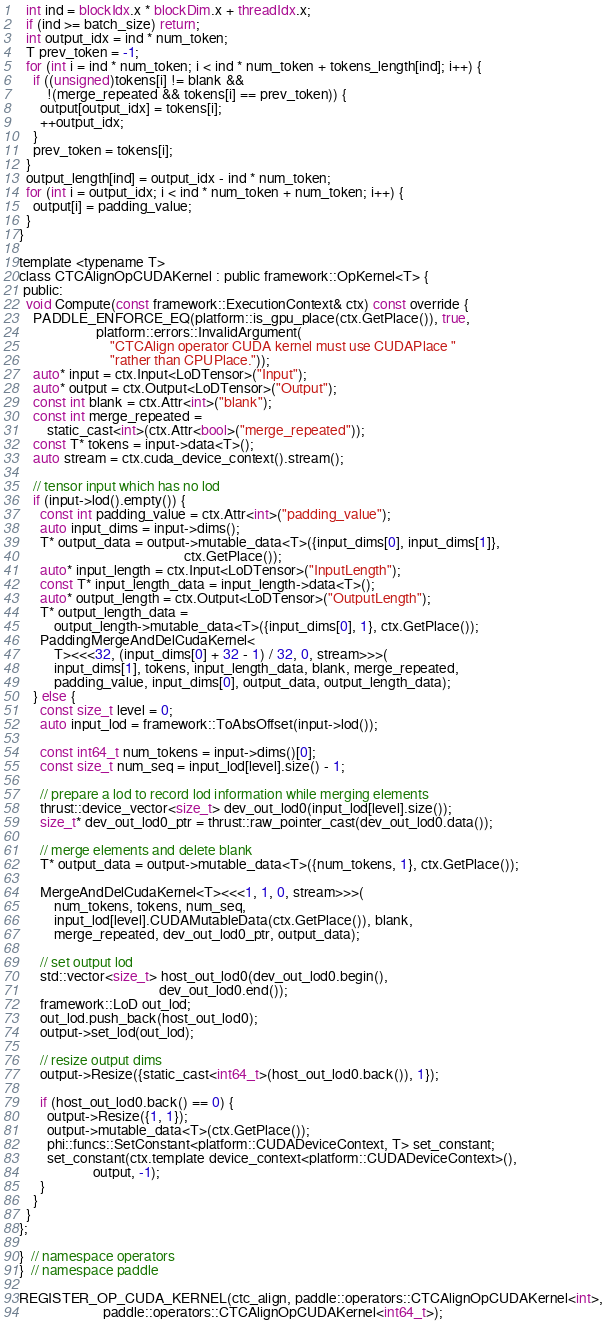<code> <loc_0><loc_0><loc_500><loc_500><_Cuda_>  int ind = blockIdx.x * blockDim.x + threadIdx.x;
  if (ind >= batch_size) return;
  int output_idx = ind * num_token;
  T prev_token = -1;
  for (int i = ind * num_token; i < ind * num_token + tokens_length[ind]; i++) {
    if ((unsigned)tokens[i] != blank &&
        !(merge_repeated && tokens[i] == prev_token)) {
      output[output_idx] = tokens[i];
      ++output_idx;
    }
    prev_token = tokens[i];
  }
  output_length[ind] = output_idx - ind * num_token;
  for (int i = output_idx; i < ind * num_token + num_token; i++) {
    output[i] = padding_value;
  }
}

template <typename T>
class CTCAlignOpCUDAKernel : public framework::OpKernel<T> {
 public:
  void Compute(const framework::ExecutionContext& ctx) const override {
    PADDLE_ENFORCE_EQ(platform::is_gpu_place(ctx.GetPlace()), true,
                      platform::errors::InvalidArgument(
                          "CTCAlign operator CUDA kernel must use CUDAPlace "
                          "rather than CPUPlace."));
    auto* input = ctx.Input<LoDTensor>("Input");
    auto* output = ctx.Output<LoDTensor>("Output");
    const int blank = ctx.Attr<int>("blank");
    const int merge_repeated =
        static_cast<int>(ctx.Attr<bool>("merge_repeated"));
    const T* tokens = input->data<T>();
    auto stream = ctx.cuda_device_context().stream();

    // tensor input which has no lod
    if (input->lod().empty()) {
      const int padding_value = ctx.Attr<int>("padding_value");
      auto input_dims = input->dims();
      T* output_data = output->mutable_data<T>({input_dims[0], input_dims[1]},
                                               ctx.GetPlace());
      auto* input_length = ctx.Input<LoDTensor>("InputLength");
      const T* input_length_data = input_length->data<T>();
      auto* output_length = ctx.Output<LoDTensor>("OutputLength");
      T* output_length_data =
          output_length->mutable_data<T>({input_dims[0], 1}, ctx.GetPlace());
      PaddingMergeAndDelCudaKernel<
          T><<<32, (input_dims[0] + 32 - 1) / 32, 0, stream>>>(
          input_dims[1], tokens, input_length_data, blank, merge_repeated,
          padding_value, input_dims[0], output_data, output_length_data);
    } else {
      const size_t level = 0;
      auto input_lod = framework::ToAbsOffset(input->lod());

      const int64_t num_tokens = input->dims()[0];
      const size_t num_seq = input_lod[level].size() - 1;

      // prepare a lod to record lod information while merging elements
      thrust::device_vector<size_t> dev_out_lod0(input_lod[level].size());
      size_t* dev_out_lod0_ptr = thrust::raw_pointer_cast(dev_out_lod0.data());

      // merge elements and delete blank
      T* output_data = output->mutable_data<T>({num_tokens, 1}, ctx.GetPlace());

      MergeAndDelCudaKernel<T><<<1, 1, 0, stream>>>(
          num_tokens, tokens, num_seq,
          input_lod[level].CUDAMutableData(ctx.GetPlace()), blank,
          merge_repeated, dev_out_lod0_ptr, output_data);

      // set output lod
      std::vector<size_t> host_out_lod0(dev_out_lod0.begin(),
                                        dev_out_lod0.end());
      framework::LoD out_lod;
      out_lod.push_back(host_out_lod0);
      output->set_lod(out_lod);

      // resize output dims
      output->Resize({static_cast<int64_t>(host_out_lod0.back()), 1});

      if (host_out_lod0.back() == 0) {
        output->Resize({1, 1});
        output->mutable_data<T>(ctx.GetPlace());
        phi::funcs::SetConstant<platform::CUDADeviceContext, T> set_constant;
        set_constant(ctx.template device_context<platform::CUDADeviceContext>(),
                     output, -1);
      }
    }
  }
};

}  // namespace operators
}  // namespace paddle

REGISTER_OP_CUDA_KERNEL(ctc_align, paddle::operators::CTCAlignOpCUDAKernel<int>,
                        paddle::operators::CTCAlignOpCUDAKernel<int64_t>);
</code> 